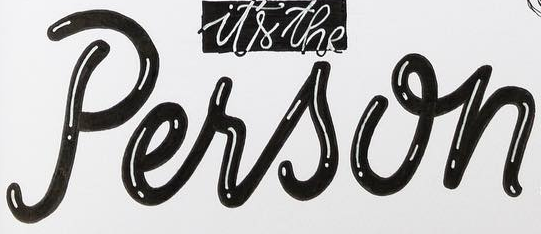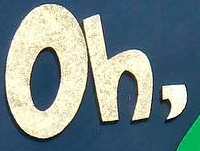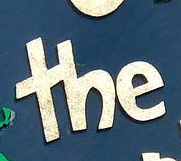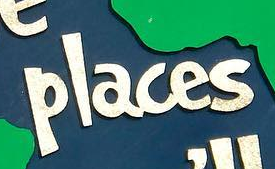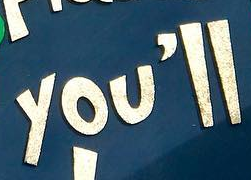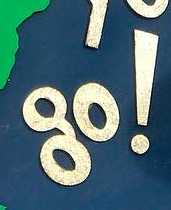What text appears in these images from left to right, separated by a semicolon? Person; Oh,; the; places; you'll; go! 